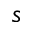<formula> <loc_0><loc_0><loc_500><loc_500>s</formula> 